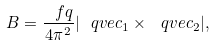Convert formula to latex. <formula><loc_0><loc_0><loc_500><loc_500>B = \frac { \ f q } { 4 \pi ^ { 2 } } | \ q v e c _ { 1 } \times \ q v e c _ { 2 } | ,</formula> 